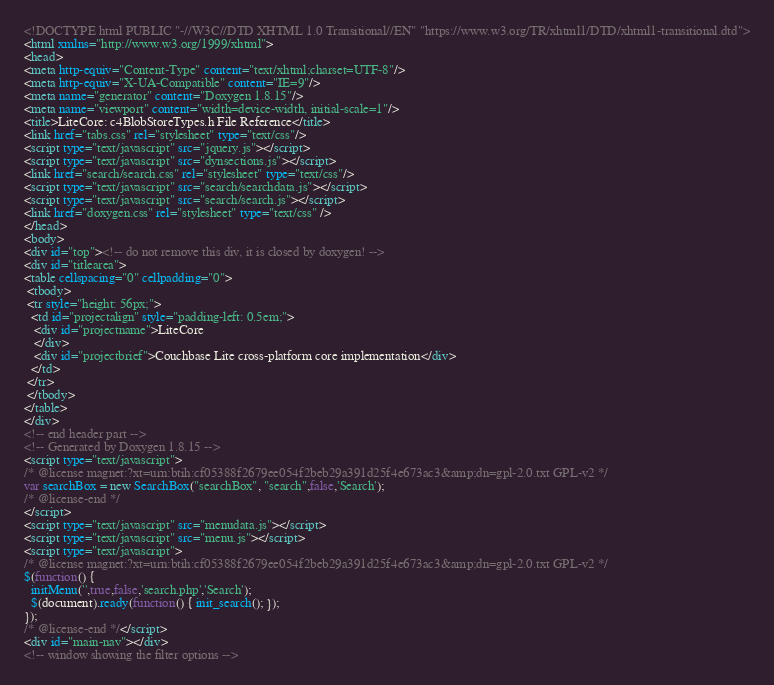<code> <loc_0><loc_0><loc_500><loc_500><_HTML_><!DOCTYPE html PUBLIC "-//W3C//DTD XHTML 1.0 Transitional//EN" "https://www.w3.org/TR/xhtml1/DTD/xhtml1-transitional.dtd">
<html xmlns="http://www.w3.org/1999/xhtml">
<head>
<meta http-equiv="Content-Type" content="text/xhtml;charset=UTF-8"/>
<meta http-equiv="X-UA-Compatible" content="IE=9"/>
<meta name="generator" content="Doxygen 1.8.15"/>
<meta name="viewport" content="width=device-width, initial-scale=1"/>
<title>LiteCore: c4BlobStoreTypes.h File Reference</title>
<link href="tabs.css" rel="stylesheet" type="text/css"/>
<script type="text/javascript" src="jquery.js"></script>
<script type="text/javascript" src="dynsections.js"></script>
<link href="search/search.css" rel="stylesheet" type="text/css"/>
<script type="text/javascript" src="search/searchdata.js"></script>
<script type="text/javascript" src="search/search.js"></script>
<link href="doxygen.css" rel="stylesheet" type="text/css" />
</head>
<body>
<div id="top"><!-- do not remove this div, it is closed by doxygen! -->
<div id="titlearea">
<table cellspacing="0" cellpadding="0">
 <tbody>
 <tr style="height: 56px;">
  <td id="projectalign" style="padding-left: 0.5em;">
   <div id="projectname">LiteCore
   </div>
   <div id="projectbrief">Couchbase Lite cross-platform core implementation</div>
  </td>
 </tr>
 </tbody>
</table>
</div>
<!-- end header part -->
<!-- Generated by Doxygen 1.8.15 -->
<script type="text/javascript">
/* @license magnet:?xt=urn:btih:cf05388f2679ee054f2beb29a391d25f4e673ac3&amp;dn=gpl-2.0.txt GPL-v2 */
var searchBox = new SearchBox("searchBox", "search",false,'Search');
/* @license-end */
</script>
<script type="text/javascript" src="menudata.js"></script>
<script type="text/javascript" src="menu.js"></script>
<script type="text/javascript">
/* @license magnet:?xt=urn:btih:cf05388f2679ee054f2beb29a391d25f4e673ac3&amp;dn=gpl-2.0.txt GPL-v2 */
$(function() {
  initMenu('',true,false,'search.php','Search');
  $(document).ready(function() { init_search(); });
});
/* @license-end */</script>
<div id="main-nav"></div>
<!-- window showing the filter options --></code> 